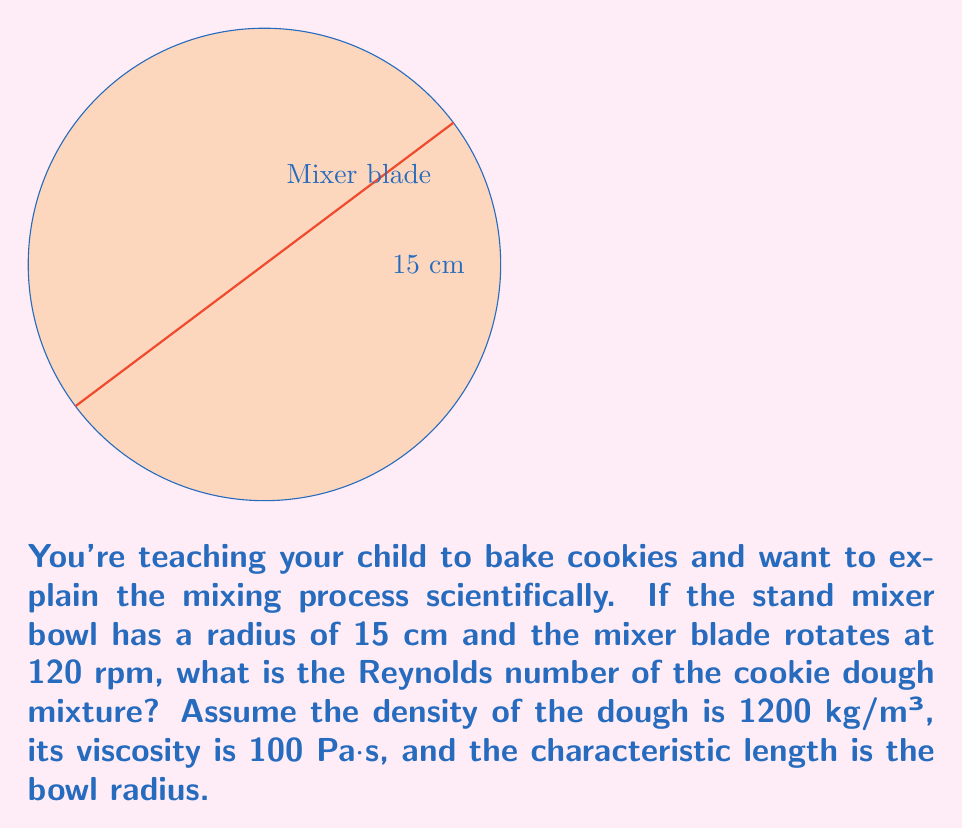Solve this math problem. To calculate the Reynolds number, we'll use the formula:

$$ Re = \frac{\rho v L}{\mu} $$

Where:
- $\rho$ is the density of the fluid (cookie dough)
- $v$ is the characteristic velocity
- $L$ is the characteristic length
- $\mu$ is the dynamic viscosity

Given:
- $\rho = 1200 \text{ kg/m³}$
- $L = 15 \text{ cm} = 0.15 \text{ m}$
- $\mu = 100 \text{ Pa·s}$
- Rotation speed = 120 rpm

Step 1: Calculate the characteristic velocity
Convert rpm to rad/s: $120 \text{ rpm} = 2 \text{ rev/s} = 4\pi \text{ rad/s}$
Velocity at the edge of the bowl: $v = \omega r = 4\pi \cdot 0.15 = 1.885 \text{ m/s}$

Step 2: Apply the Reynolds number formula
$$ Re = \frac{1200 \cdot 1.885 \cdot 0.15}{100} = 3.393 $$

Step 3: Round to the nearest whole number
$$ Re \approx 3 $$
Answer: 3 